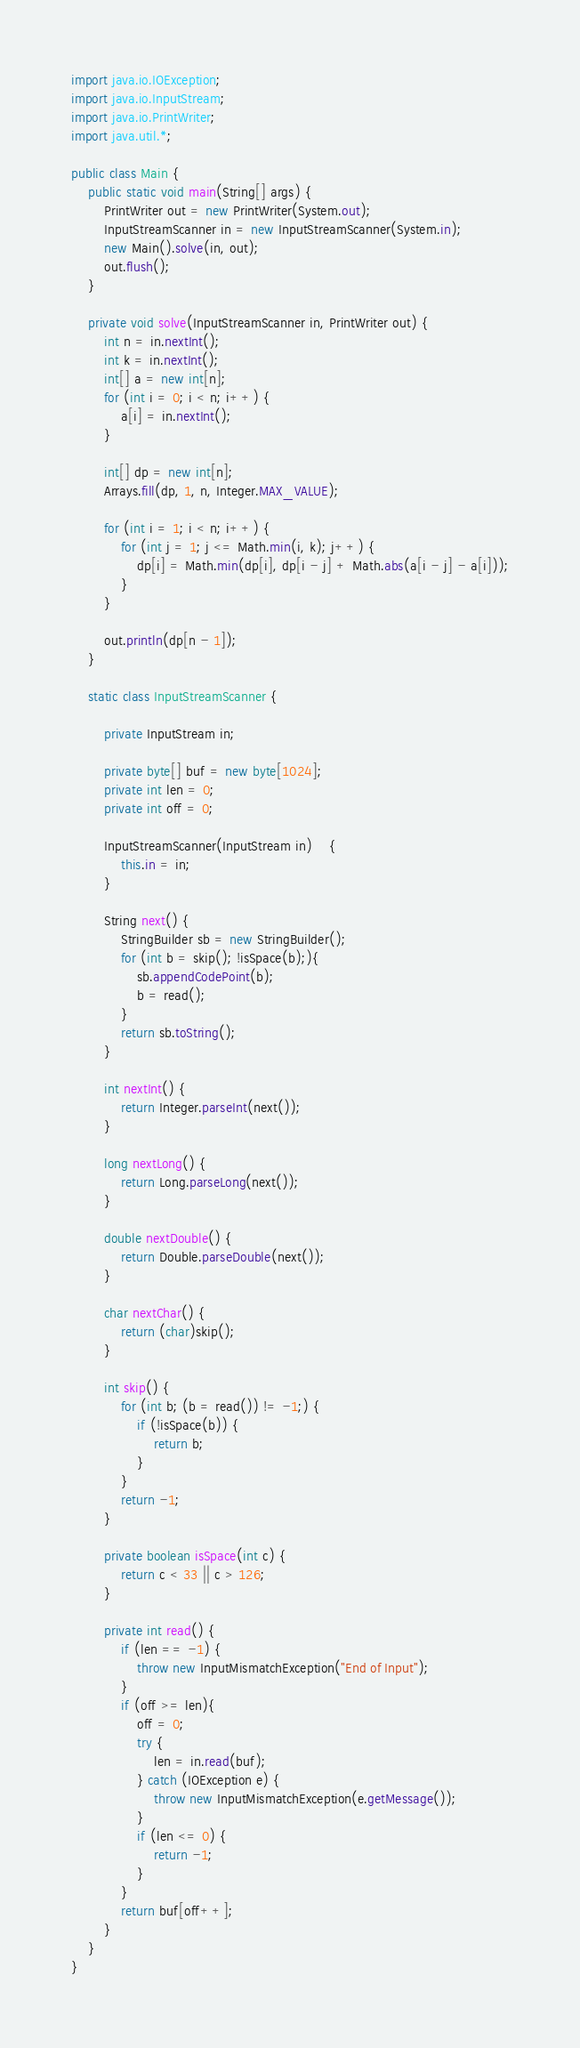<code> <loc_0><loc_0><loc_500><loc_500><_Java_>import java.io.IOException;
import java.io.InputStream;
import java.io.PrintWriter;
import java.util.*;

public class Main {
    public static void main(String[] args) {
        PrintWriter out = new PrintWriter(System.out);
        InputStreamScanner in = new InputStreamScanner(System.in);
        new Main().solve(in, out);
        out.flush();
    }

    private void solve(InputStreamScanner in, PrintWriter out) {
        int n = in.nextInt();
        int k = in.nextInt();
        int[] a = new int[n];
        for (int i = 0; i < n; i++) {
            a[i] = in.nextInt();
        }

        int[] dp = new int[n];
        Arrays.fill(dp, 1, n, Integer.MAX_VALUE);

        for (int i = 1; i < n; i++) {
            for (int j = 1; j <= Math.min(i, k); j++) {
                dp[i] = Math.min(dp[i], dp[i - j] + Math.abs(a[i - j] - a[i]));
            }
        }

        out.println(dp[n - 1]);
    }

    static class InputStreamScanner {

        private InputStream in;

        private byte[] buf = new byte[1024];
        private int len = 0;
        private int off = 0;

        InputStreamScanner(InputStream in)	{
            this.in = in;
        }

        String next() {
            StringBuilder sb = new StringBuilder();
            for (int b = skip(); !isSpace(b);){
                sb.appendCodePoint(b);
                b = read();
            }
            return sb.toString();
        }

        int nextInt() {
            return Integer.parseInt(next());
        }

        long nextLong() {
            return Long.parseLong(next());
        }

        double nextDouble() {
            return Double.parseDouble(next());
        }

        char nextChar() {
            return (char)skip();
        }

        int skip() {
            for (int b; (b = read()) != -1;) {
                if (!isSpace(b)) {
                    return b;
                }
            }
            return -1;
        }

        private boolean isSpace(int c) {
            return c < 33 || c > 126;
        }

        private int read() {
            if (len == -1) {
                throw new InputMismatchException("End of Input");
            }
            if (off >= len){
                off = 0;
                try {
                    len = in.read(buf);
                } catch (IOException e) {
                    throw new InputMismatchException(e.getMessage());
                }
                if (len <= 0) {
                    return -1;
                }
            }
            return buf[off++];
        }
    }
}
</code> 